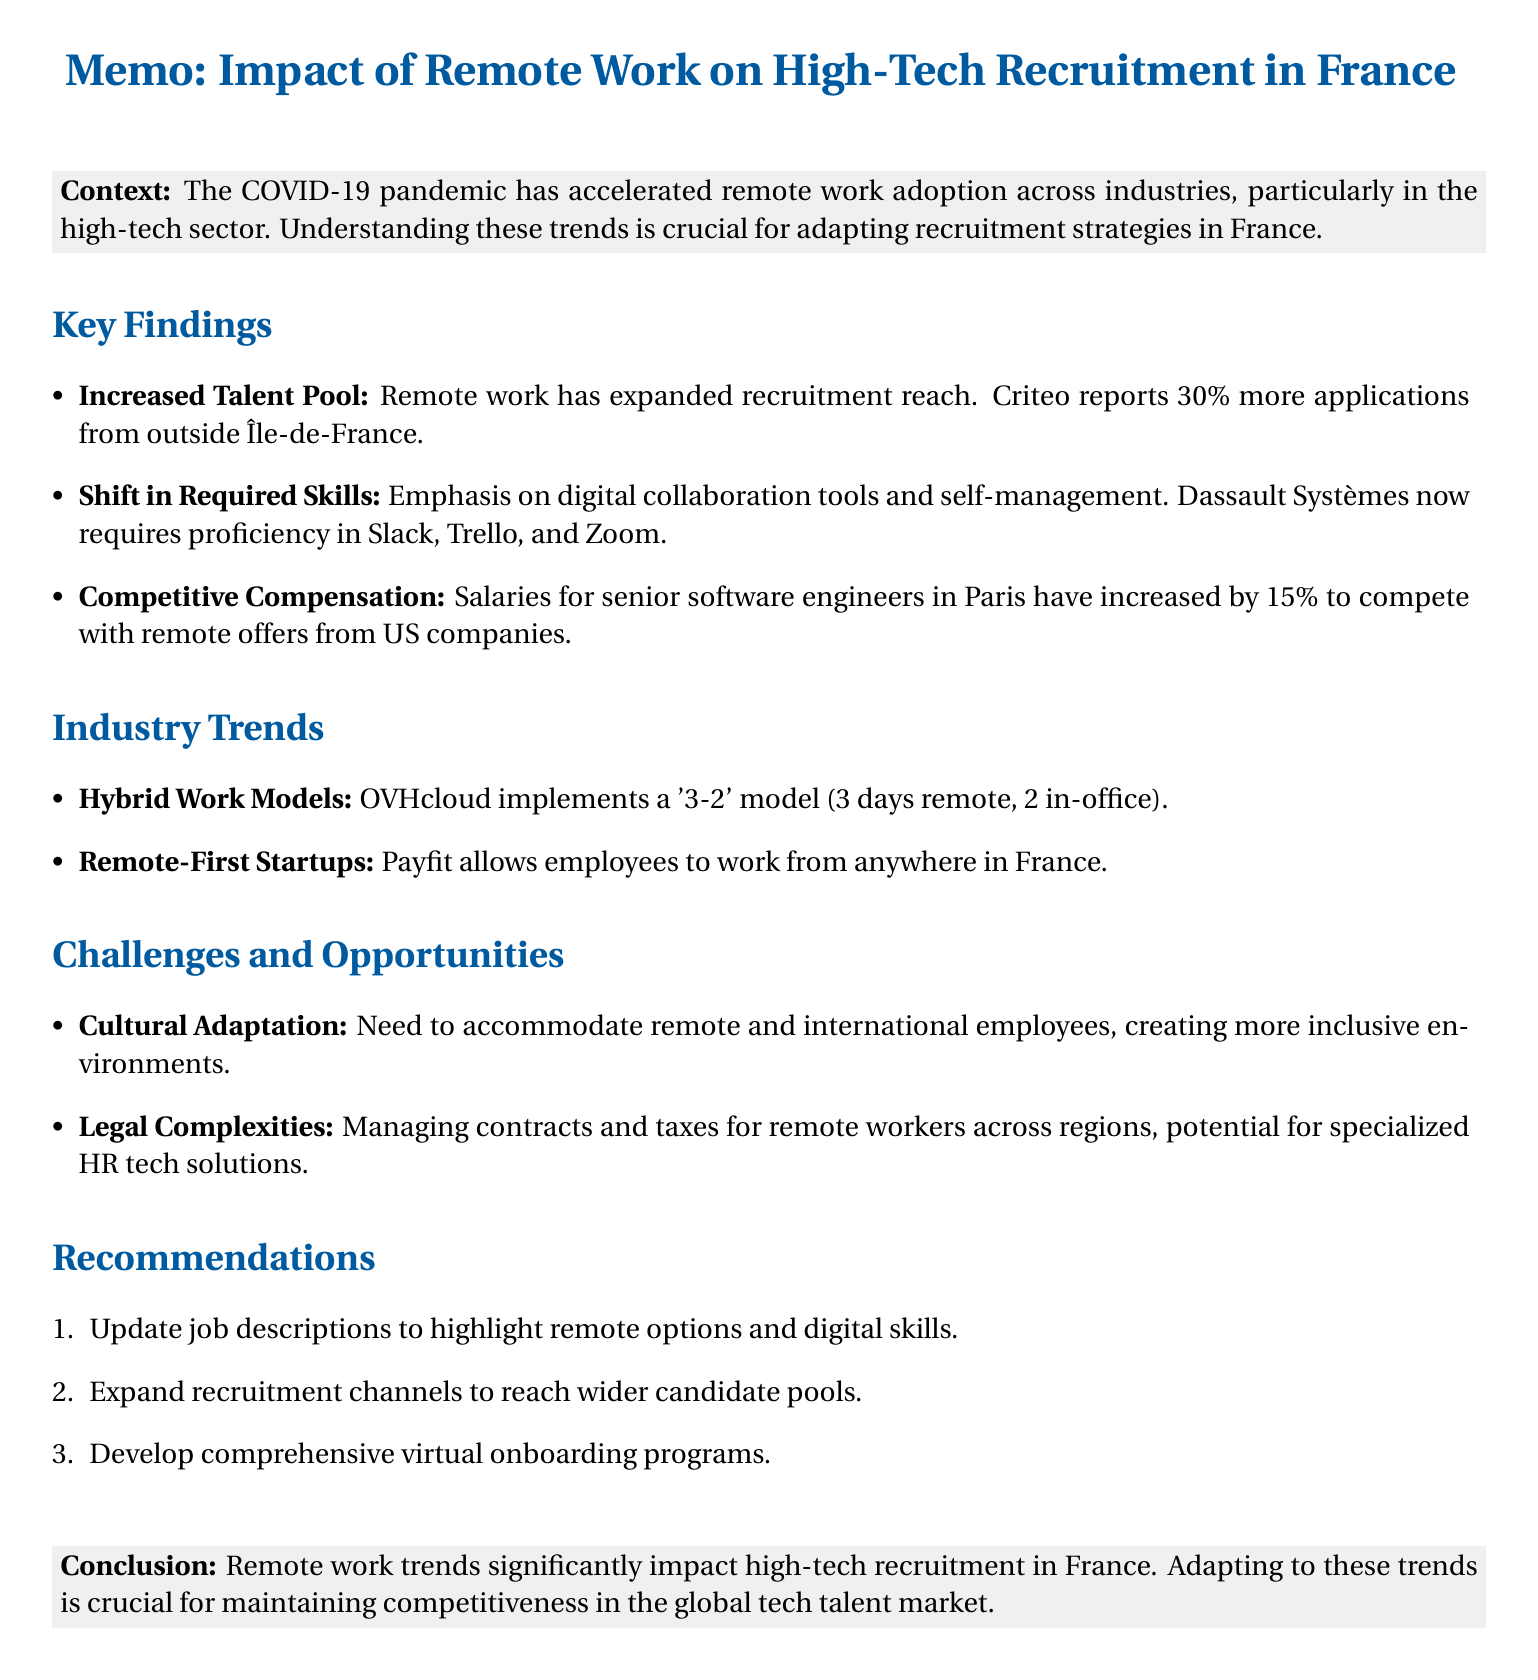what has expanded the talent pool for high-tech companies in France? The increase in remote work has expanded the talent pool for French high-tech companies.
Answer: remote work what company reported a 30% increase in applications from outside the Île-de-France region? Criteo, a Paris-based adtech company, reported a 30% increase in applications.
Answer: Criteo what percentage have salaries for senior software engineers in Paris increased by in the past year? The document states that salaries for senior software engineers in Paris have increased by 15%.
Answer: 15% what model has OVHcloud implemented for their hybrid work? OVHcloud has implemented a '3-2' model for their hybrid work.
Answer: '3-2' model what is a challenge related to remote work mentioned in the document? The document mentions managing employment contracts and taxes for remote workers as a challenge.
Answer: Legal and Administrative Complexities which digital collaboration tools are mentioned as essential skills for remote positions? The document highlights tools like Slack, Trello, and Zoom as essential skills for remote roles.
Answer: Slack, Trello, Zoom how many recommendations are provided in the document? The document lists three main recommendations for adapting to remote work trends.
Answer: three what opportunity is linked to cultural adaptation? The document states that adapting to cultural work environments can provide an opportunity for diversity and inclusion.
Answer: inclusive and diverse work environments what action should be taken regarding job descriptions? The document recommends updating job descriptions to highlight remote work options and required skills.
Answer: Update Job Descriptions 